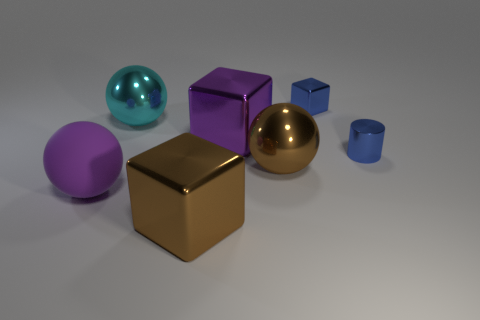Does the tiny metal thing that is on the left side of the cylinder have the same color as the tiny metallic cylinder that is behind the brown metallic block?
Your answer should be very brief. Yes. What number of metallic objects are big red cubes or cyan objects?
Make the answer very short. 1. There is a large cyan metal sphere that is to the left of the small blue metallic thing that is left of the metallic cylinder; how many purple spheres are in front of it?
Give a very brief answer. 1. What is the size of the blue block that is made of the same material as the purple block?
Keep it short and to the point. Small. What number of metallic things have the same color as the tiny block?
Your response must be concise. 1. Does the thing in front of the purple sphere have the same size as the tiny block?
Your answer should be compact. No. The large ball that is to the right of the large purple matte object and on the left side of the large brown shiny block is what color?
Make the answer very short. Cyan. How many things are either brown balls or large brown things that are behind the matte ball?
Keep it short and to the point. 1. What material is the large purple object that is in front of the tiny thing right of the block behind the large cyan sphere made of?
Provide a short and direct response. Rubber. Are there any other things that have the same material as the large purple ball?
Offer a terse response. No. 